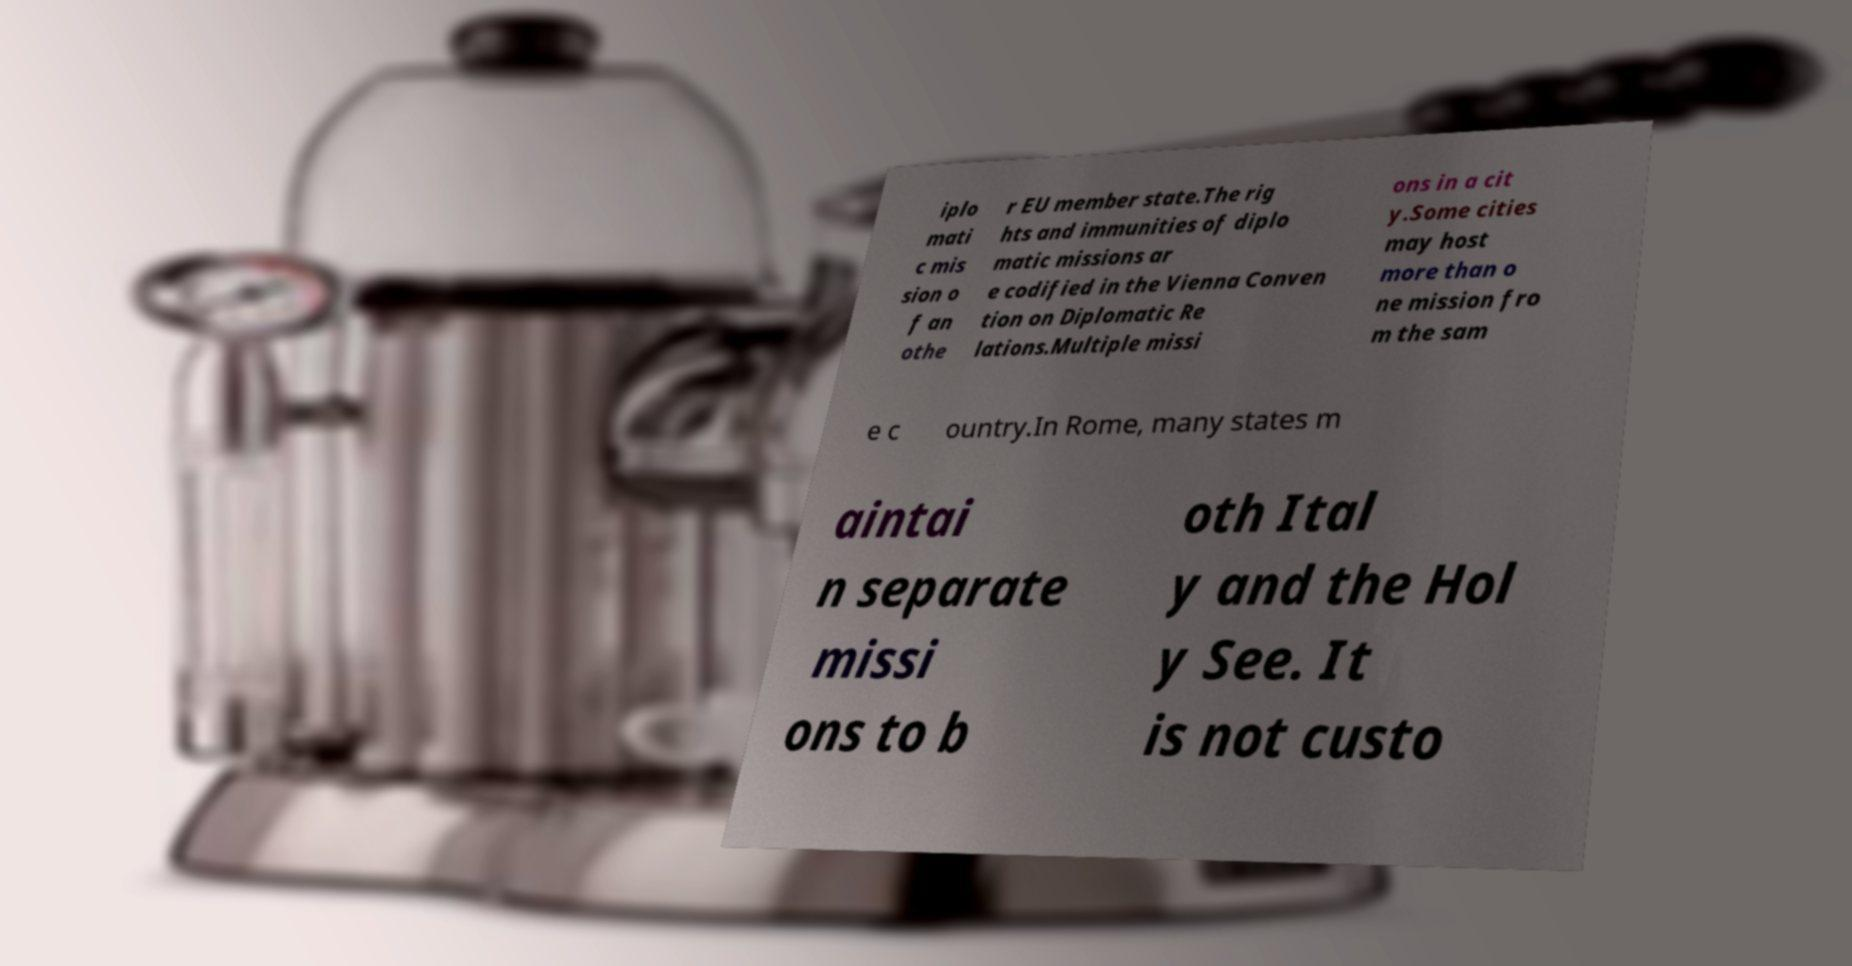Could you extract and type out the text from this image? iplo mati c mis sion o f an othe r EU member state.The rig hts and immunities of diplo matic missions ar e codified in the Vienna Conven tion on Diplomatic Re lations.Multiple missi ons in a cit y.Some cities may host more than o ne mission fro m the sam e c ountry.In Rome, many states m aintai n separate missi ons to b oth Ital y and the Hol y See. It is not custo 